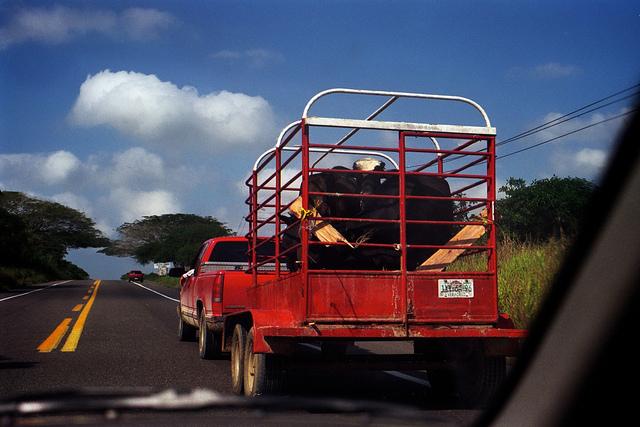Would it be legal to pass this truck now?
Concise answer only. No. What color is the truck?
Keep it brief. Red. Is this a picture of New York City?
Give a very brief answer. No. 